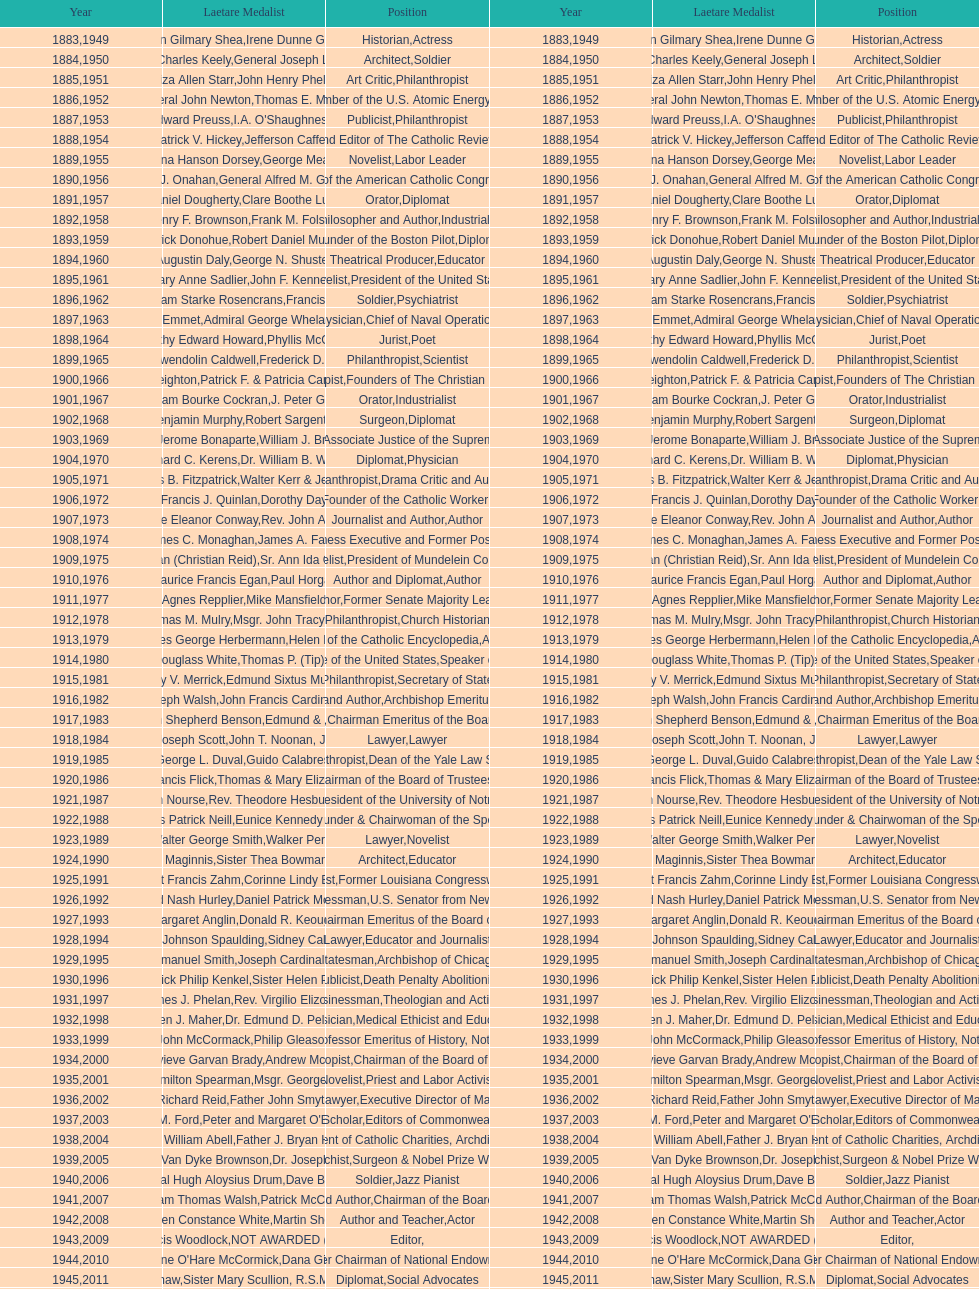What is the count of lawyers who achieved the award during the period of 1883-2014? 5. 